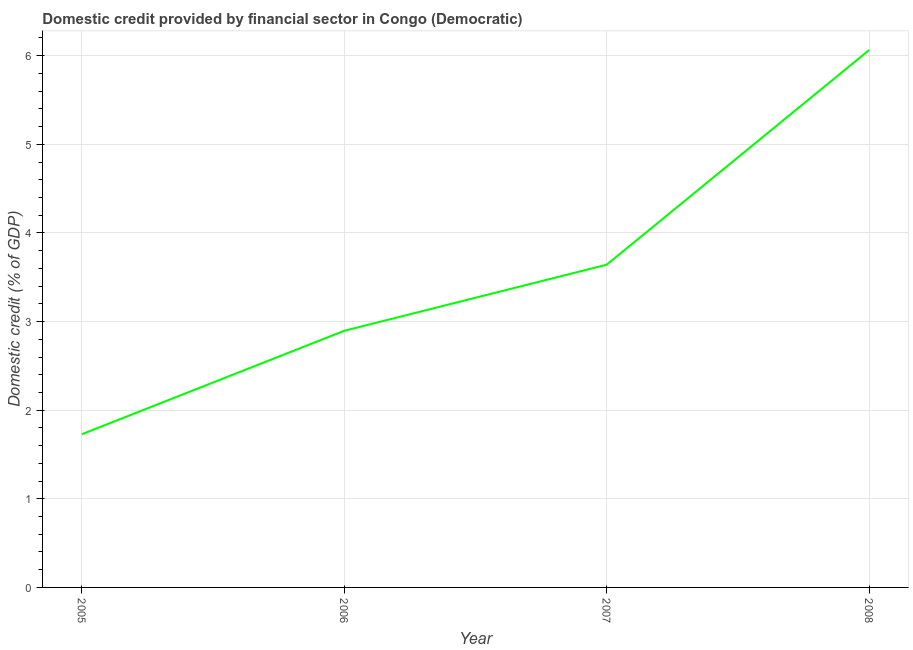What is the domestic credit provided by financial sector in 2006?
Provide a succinct answer. 2.9. Across all years, what is the maximum domestic credit provided by financial sector?
Your response must be concise. 6.06. Across all years, what is the minimum domestic credit provided by financial sector?
Ensure brevity in your answer.  1.73. In which year was the domestic credit provided by financial sector maximum?
Ensure brevity in your answer.  2008. What is the sum of the domestic credit provided by financial sector?
Keep it short and to the point. 14.33. What is the difference between the domestic credit provided by financial sector in 2005 and 2007?
Your answer should be very brief. -1.91. What is the average domestic credit provided by financial sector per year?
Ensure brevity in your answer.  3.58. What is the median domestic credit provided by financial sector?
Give a very brief answer. 3.27. What is the ratio of the domestic credit provided by financial sector in 2005 to that in 2007?
Provide a succinct answer. 0.47. Is the difference between the domestic credit provided by financial sector in 2005 and 2006 greater than the difference between any two years?
Your answer should be compact. No. What is the difference between the highest and the second highest domestic credit provided by financial sector?
Your response must be concise. 2.42. Is the sum of the domestic credit provided by financial sector in 2007 and 2008 greater than the maximum domestic credit provided by financial sector across all years?
Ensure brevity in your answer.  Yes. What is the difference between the highest and the lowest domestic credit provided by financial sector?
Provide a short and direct response. 4.34. How many years are there in the graph?
Your response must be concise. 4. Are the values on the major ticks of Y-axis written in scientific E-notation?
Offer a very short reply. No. Does the graph contain grids?
Ensure brevity in your answer.  Yes. What is the title of the graph?
Provide a succinct answer. Domestic credit provided by financial sector in Congo (Democratic). What is the label or title of the X-axis?
Your answer should be very brief. Year. What is the label or title of the Y-axis?
Your answer should be very brief. Domestic credit (% of GDP). What is the Domestic credit (% of GDP) of 2005?
Your response must be concise. 1.73. What is the Domestic credit (% of GDP) in 2006?
Keep it short and to the point. 2.9. What is the Domestic credit (% of GDP) in 2007?
Your response must be concise. 3.64. What is the Domestic credit (% of GDP) in 2008?
Offer a terse response. 6.06. What is the difference between the Domestic credit (% of GDP) in 2005 and 2006?
Offer a very short reply. -1.17. What is the difference between the Domestic credit (% of GDP) in 2005 and 2007?
Your answer should be very brief. -1.91. What is the difference between the Domestic credit (% of GDP) in 2005 and 2008?
Your answer should be very brief. -4.34. What is the difference between the Domestic credit (% of GDP) in 2006 and 2007?
Offer a terse response. -0.75. What is the difference between the Domestic credit (% of GDP) in 2006 and 2008?
Ensure brevity in your answer.  -3.17. What is the difference between the Domestic credit (% of GDP) in 2007 and 2008?
Your response must be concise. -2.42. What is the ratio of the Domestic credit (% of GDP) in 2005 to that in 2006?
Offer a very short reply. 0.6. What is the ratio of the Domestic credit (% of GDP) in 2005 to that in 2007?
Your answer should be very brief. 0.47. What is the ratio of the Domestic credit (% of GDP) in 2005 to that in 2008?
Your answer should be compact. 0.28. What is the ratio of the Domestic credit (% of GDP) in 2006 to that in 2007?
Provide a short and direct response. 0.8. What is the ratio of the Domestic credit (% of GDP) in 2006 to that in 2008?
Make the answer very short. 0.48. What is the ratio of the Domestic credit (% of GDP) in 2007 to that in 2008?
Your response must be concise. 0.6. 